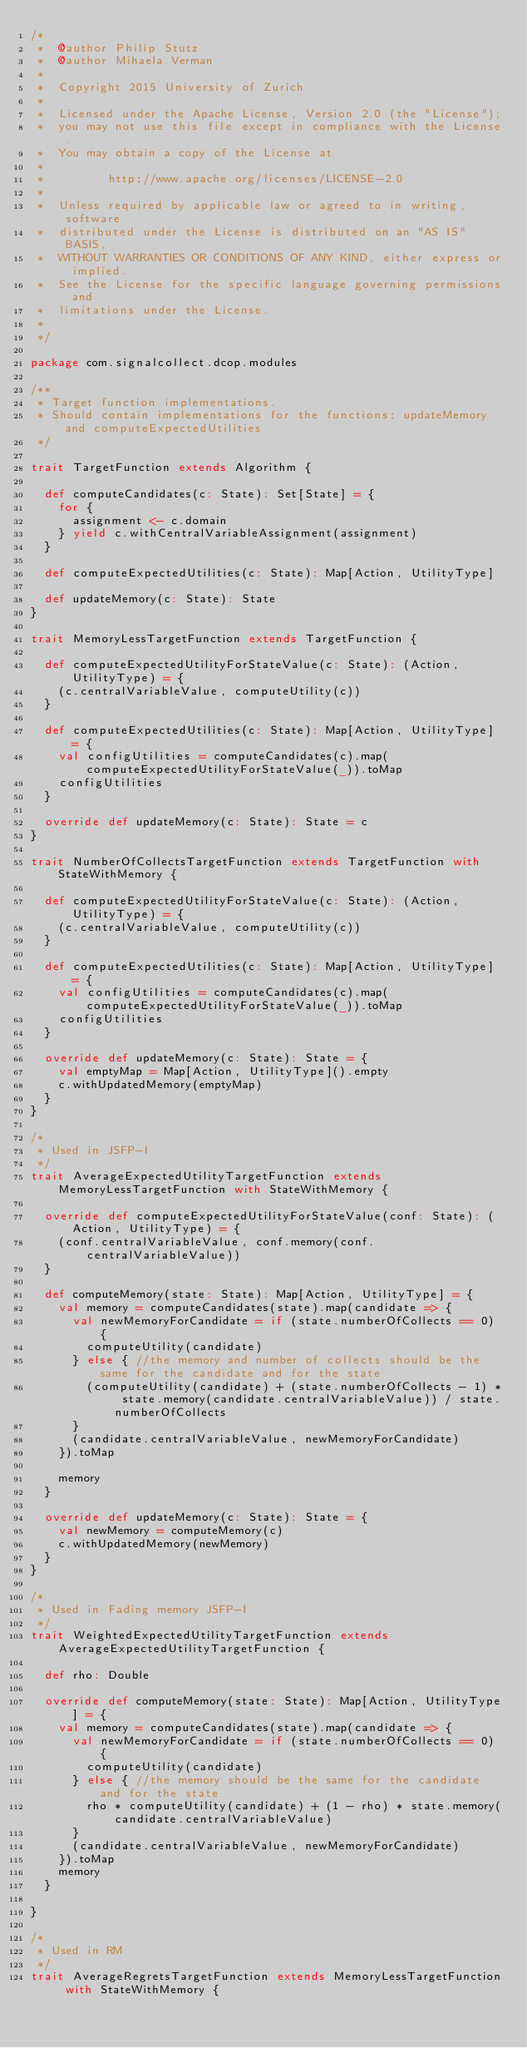Convert code to text. <code><loc_0><loc_0><loc_500><loc_500><_Scala_>/*
 *  @author Philip Stutz
 *  @author Mihaela Verman
 *  
 *  Copyright 2015 University of Zurich
 *      
 *  Licensed under the Apache License, Version 2.0 (the "License");
 *  you may not use this file except in compliance with the License.
 *  You may obtain a copy of the License at
 *  
 *         http://www.apache.org/licenses/LICENSE-2.0
 *  
 *  Unless required by applicable law or agreed to in writing, software
 *  distributed under the License is distributed on an "AS IS" BASIS,
 *  WITHOUT WARRANTIES OR CONDITIONS OF ANY KIND, either express or implied.
 *  See the License for the specific language governing permissions and
 *  limitations under the License.
 *  
 */

package com.signalcollect.dcop.modules

/**
 * Target function implementations.
 * Should contain implementations for the functions: updateMemory and computeExpectedUtilities
 */

trait TargetFunction extends Algorithm {

  def computeCandidates(c: State): Set[State] = {
    for {
      assignment <- c.domain
    } yield c.withCentralVariableAssignment(assignment)
  }

  def computeExpectedUtilities(c: State): Map[Action, UtilityType]

  def updateMemory(c: State): State
}

trait MemoryLessTargetFunction extends TargetFunction {

  def computeExpectedUtilityForStateValue(c: State): (Action, UtilityType) = {
    (c.centralVariableValue, computeUtility(c))
  }

  def computeExpectedUtilities(c: State): Map[Action, UtilityType] = {
    val configUtilities = computeCandidates(c).map(computeExpectedUtilityForStateValue(_)).toMap
    configUtilities
  }

  override def updateMemory(c: State): State = c
}

trait NumberOfCollectsTargetFunction extends TargetFunction with StateWithMemory {

  def computeExpectedUtilityForStateValue(c: State): (Action, UtilityType) = {
    (c.centralVariableValue, computeUtility(c))
  }

  def computeExpectedUtilities(c: State): Map[Action, UtilityType] = {
    val configUtilities = computeCandidates(c).map(computeExpectedUtilityForStateValue(_)).toMap
    configUtilities
  }

  override def updateMemory(c: State): State = {
    val emptyMap = Map[Action, UtilityType]().empty
    c.withUpdatedMemory(emptyMap)
  }
}

/*
 * Used in JSFP-I
 */
trait AverageExpectedUtilityTargetFunction extends MemoryLessTargetFunction with StateWithMemory {

  override def computeExpectedUtilityForStateValue(conf: State): (Action, UtilityType) = {
    (conf.centralVariableValue, conf.memory(conf.centralVariableValue))
  }

  def computeMemory(state: State): Map[Action, UtilityType] = {
    val memory = computeCandidates(state).map(candidate => {
      val newMemoryForCandidate = if (state.numberOfCollects == 0) {
        computeUtility(candidate)
      } else { //the memory and number of collects should be the same for the candidate and for the state
        (computeUtility(candidate) + (state.numberOfCollects - 1) * state.memory(candidate.centralVariableValue)) / state.numberOfCollects
      }
      (candidate.centralVariableValue, newMemoryForCandidate)
    }).toMap

    memory
  }

  override def updateMemory(c: State): State = {
    val newMemory = computeMemory(c)
    c.withUpdatedMemory(newMemory)
  }
}

/*
 * Used in Fading memory JSFP-I
 */
trait WeightedExpectedUtilityTargetFunction extends AverageExpectedUtilityTargetFunction {

  def rho: Double

  override def computeMemory(state: State): Map[Action, UtilityType] = {
    val memory = computeCandidates(state).map(candidate => {
      val newMemoryForCandidate = if (state.numberOfCollects == 0) {
        computeUtility(candidate)
      } else { //the memory should be the same for the candidate and for the state
        rho * computeUtility(candidate) + (1 - rho) * state.memory(candidate.centralVariableValue)
      }
      (candidate.centralVariableValue, newMemoryForCandidate)
    }).toMap
    memory
  }

}

/*
 * Used in RM
 */
trait AverageRegretsTargetFunction extends MemoryLessTargetFunction with StateWithMemory {
</code> 